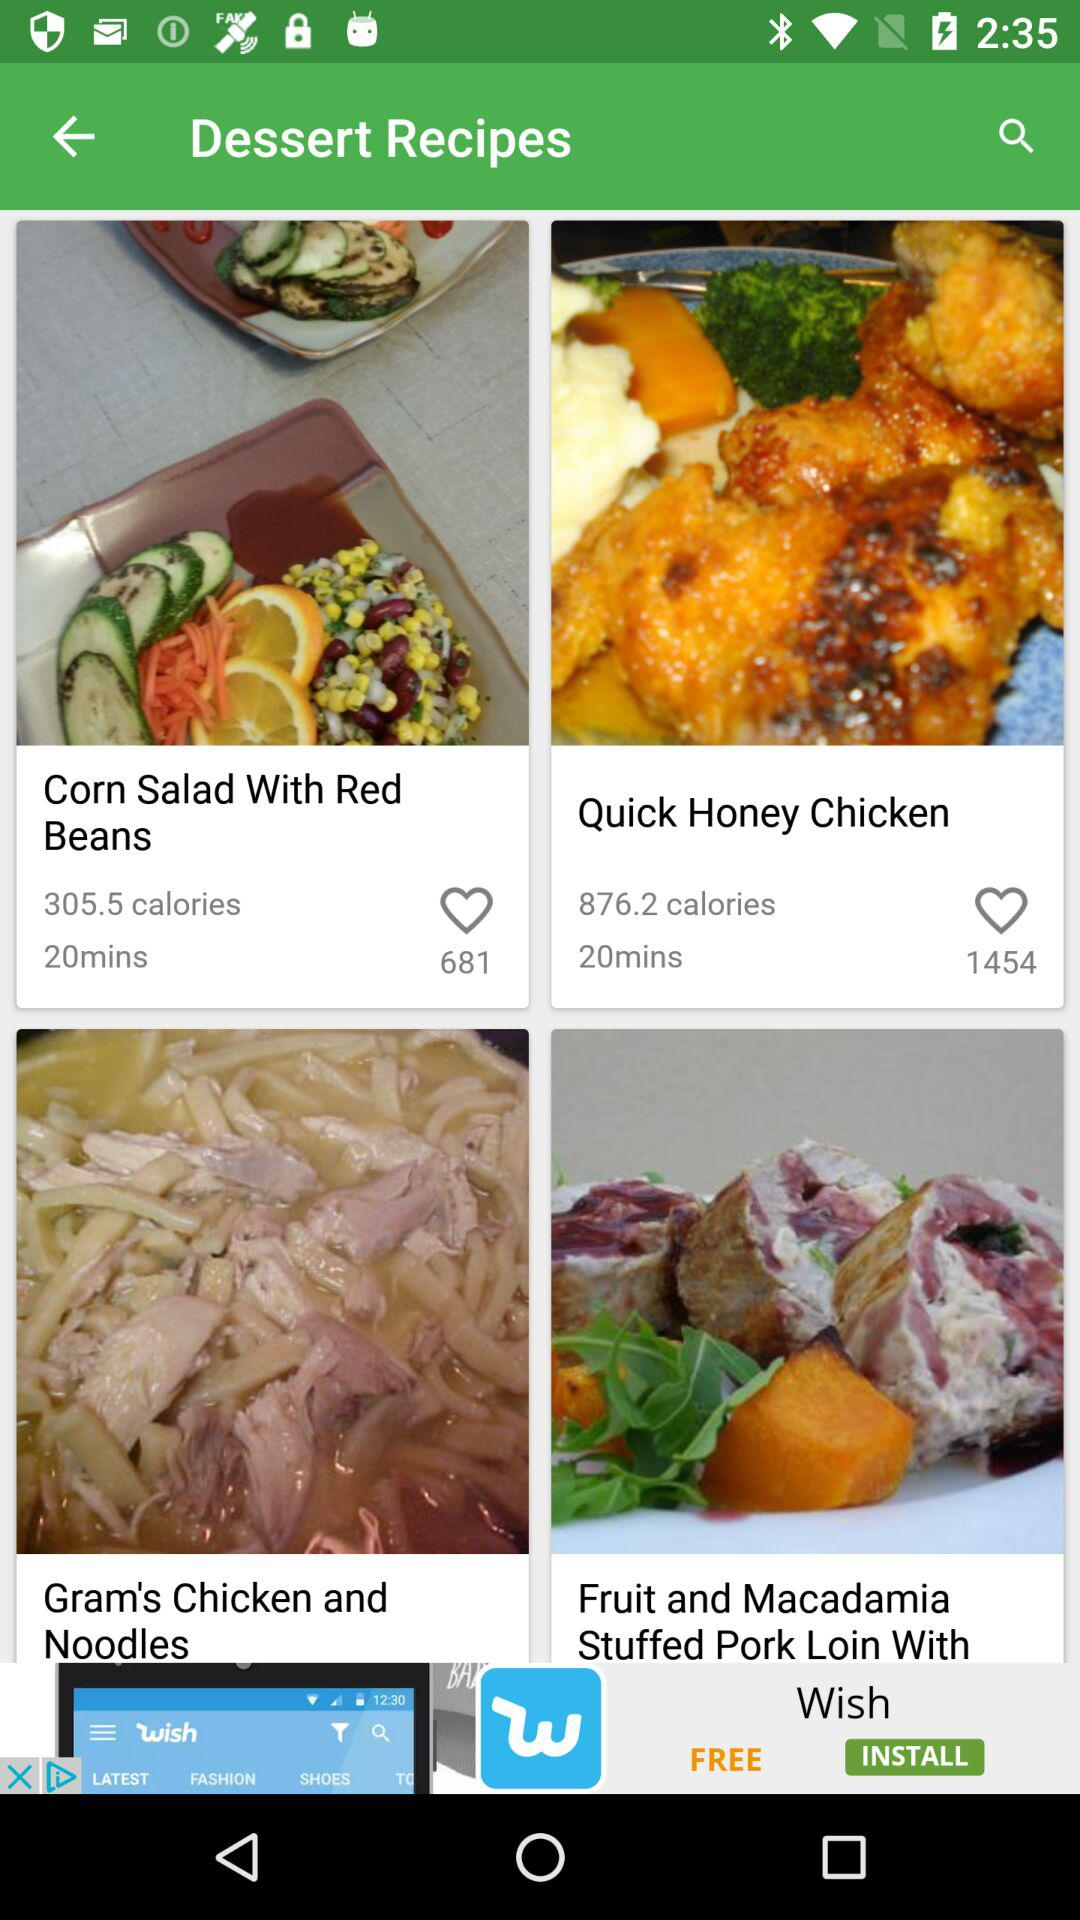How many calories are in the dish "Quick Honey Chicken"? There are 876.2 calories in the dish "Quick Honey Chicken". 